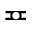Convert formula to latex. <formula><loc_0><loc_0><loc_500><loc_500>\ e q c i r c</formula> 